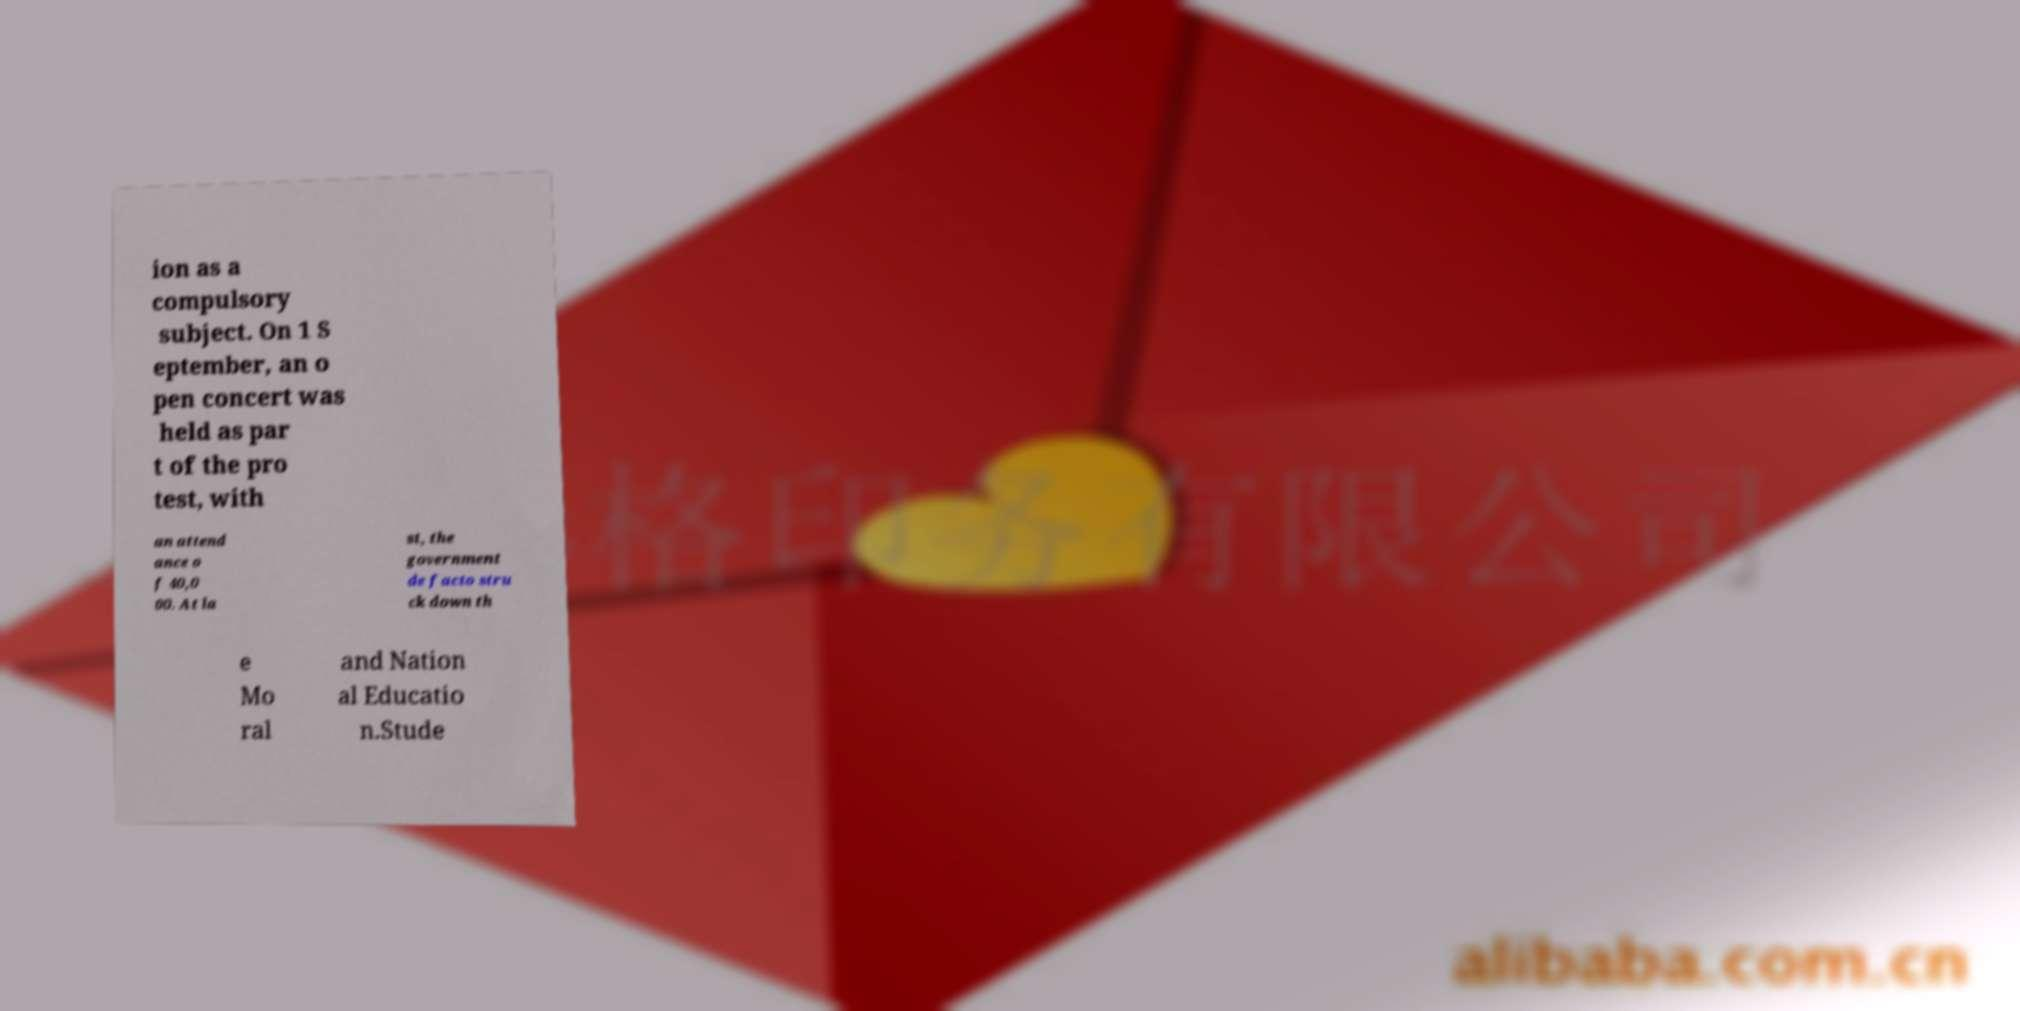Can you accurately transcribe the text from the provided image for me? ion as a compulsory subject. On 1 S eptember, an o pen concert was held as par t of the pro test, with an attend ance o f 40,0 00. At la st, the government de facto stru ck down th e Mo ral and Nation al Educatio n.Stude 